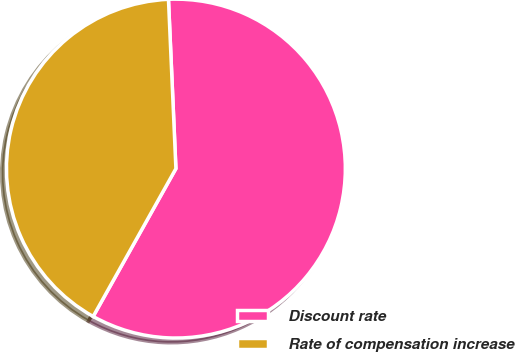Convert chart to OTSL. <chart><loc_0><loc_0><loc_500><loc_500><pie_chart><fcel>Discount rate<fcel>Rate of compensation increase<nl><fcel>58.82%<fcel>41.18%<nl></chart> 